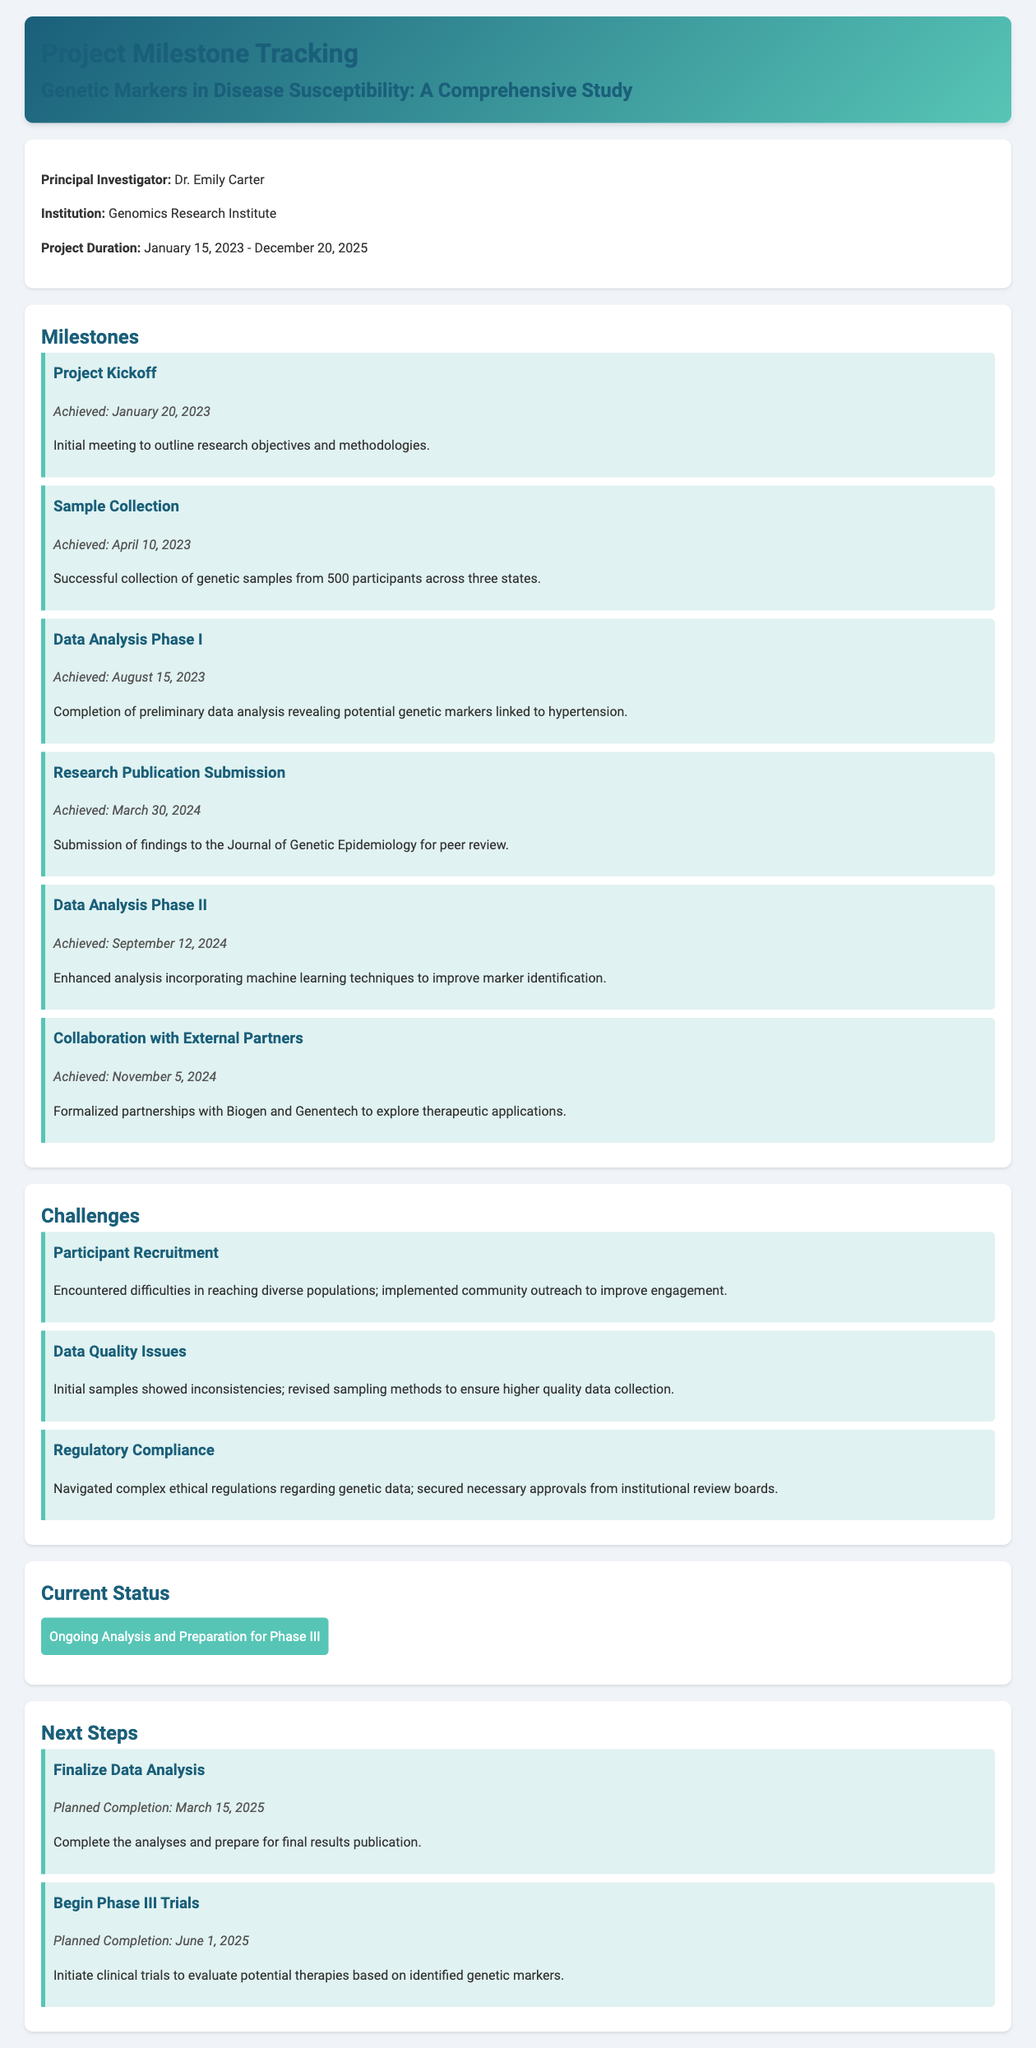What is the project's title? The title is stated in the document's header section, focusing on the genetic study.
Answer: Genetic Markers in Disease Susceptibility Who is the principal investigator? The principal investigator's name is mentioned in the document, highlighting their role in the project.
Answer: Dr. Emily Carter What is the project duration? The project duration indicates the timeline of the study in the document.
Answer: January 15, 2023 - December 20, 2025 When was the sample collection milestone achieved? The date when the sample collection milestone was achieved can be found in the milestones section.
Answer: April 10, 2023 What was a challenge mentioned in the document? The document lists several challenges; one of them is explicitly stated in the challenges section.
Answer: Participant Recruitment What is the current status of the project? The current project status is noted in the current status section, summarizing ongoing work.
Answer: Ongoing Analysis and Preparation for Phase III When is the planned completion for finalizing data analysis? The planned completion date for finalizing data analysis is specified in the next steps section.
Answer: March 15, 2025 Which external partners were mentioned for collaboration? The external partners involved in the collaboration are detailed in the respective milestone section.
Answer: Biogen and Genentech What genetic condition was initially linked to markers in the analysis? The document refers to a specific condition linked to the genetic markers discovered in the data analysis phase.
Answer: Hypertension 